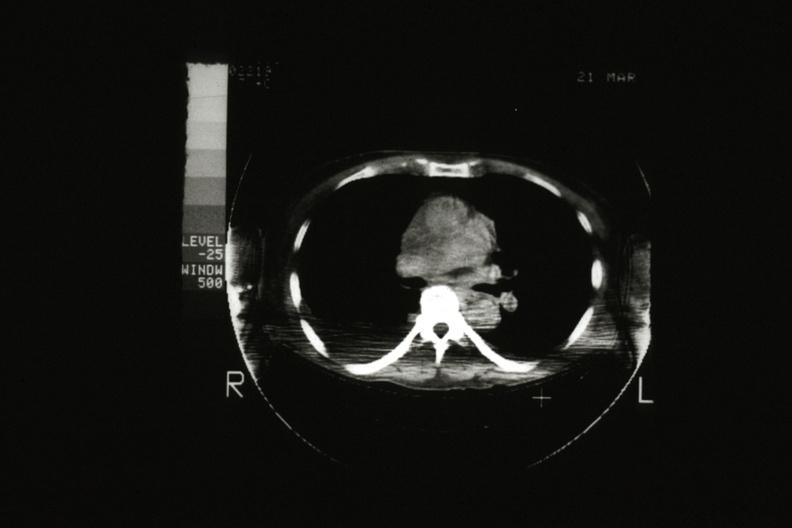what is present?
Answer the question using a single word or phrase. Hematologic 